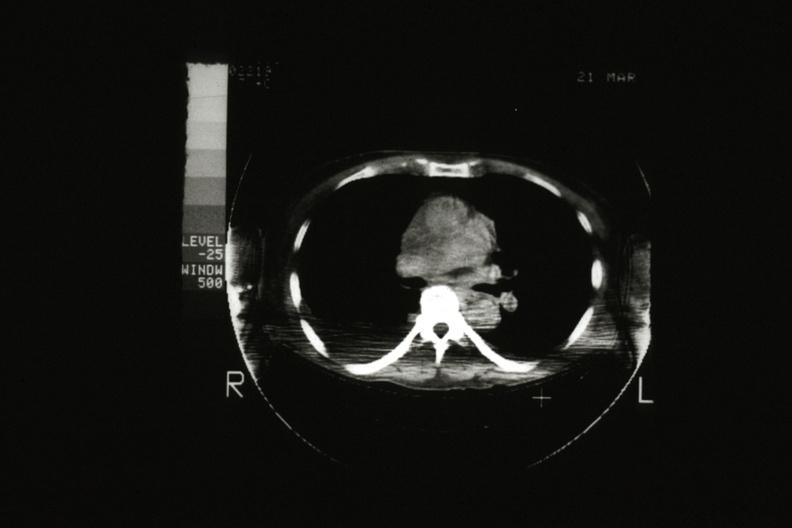what is present?
Answer the question using a single word or phrase. Hematologic 